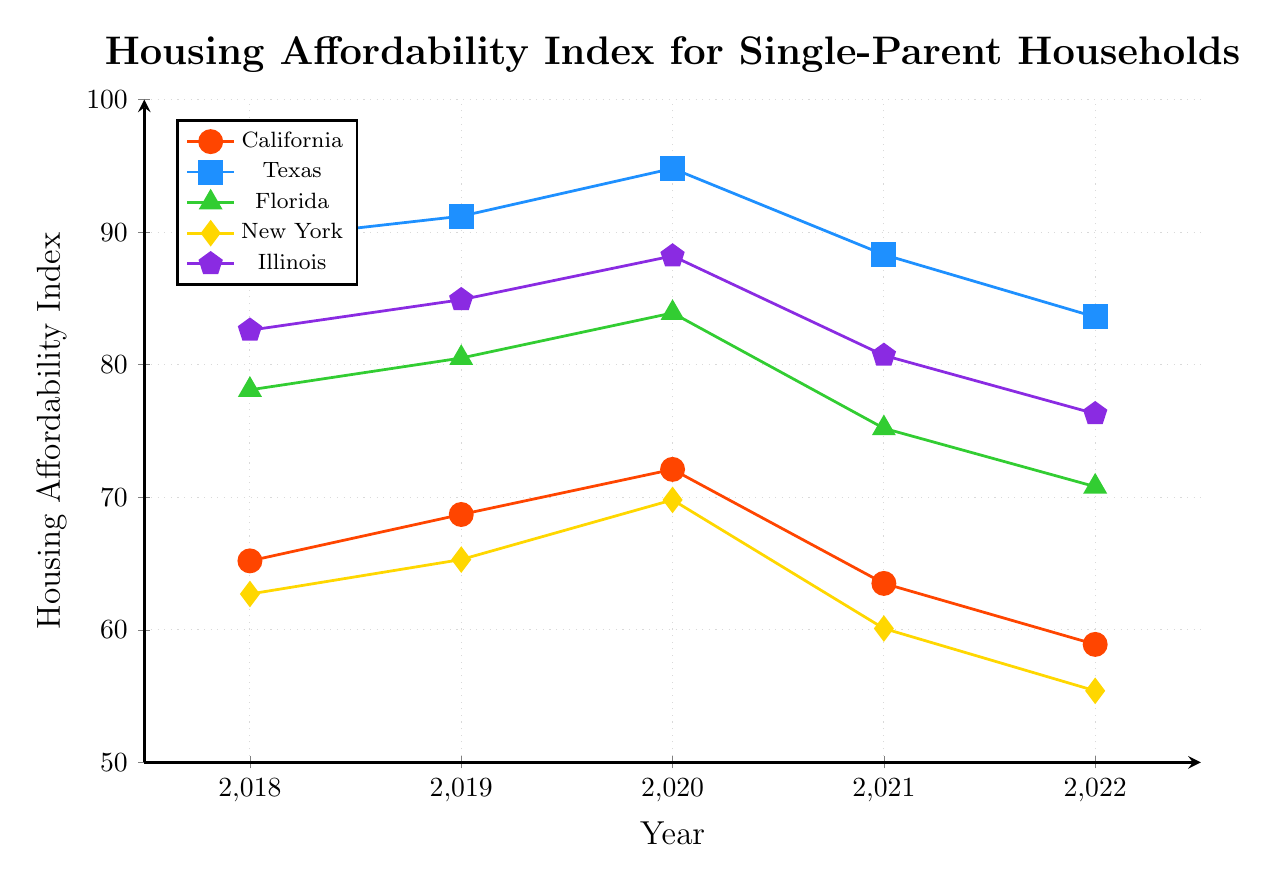What was California's Housing Affordability Index in 2020? Locate the point for California in 2020 on the x-axis, then check the y-value. The y-value is 72.1.
Answer: 72.1 Which state had the highest housing affordability index in 2022? Find the points for all states in 2022 on the x-axis and compare their y-values. Texas had the highest index (83.6).
Answer: Texas Between 2018 and 2022, which state's housing affordability index decreased the most? Calculate the difference between 2018 and 2022 values for each state: 
California: 65.2 - 58.9 = 6.3
Texas: 89.4 - 83.6 = 5.8
Florida: 78.1 - 70.8 = 7.3
New York: 62.7 - 55.4 = 7.3
Illinois: 82.6 - 76.3 = 6.3
New York and Florida both decreased the most by 7.3.
Answer: New York and Florida Compare the trends in housing affordability between California and New York from 2018 to 2022. Observe the lines for California and New York. Both states show an initial increase in affordability until 2020 followed by a decline. For California: 65.2 → 58.9 and New York: 62.7 → 55.4. Both start declining significantly after 2020.
Answer: Both states show a similar trend with an increase until 2020 and a decline afterward What is the average Housing Affordability Index for Florida from 2018 to 2022? Sum up the values for Florida from 2018 to 2022 and divide by the number of years: (78.1 + 80.5 + 83.9 + 75.2 + 70.8) / 5 = 388.5 / 5 = 77.7
Answer: 77.7 